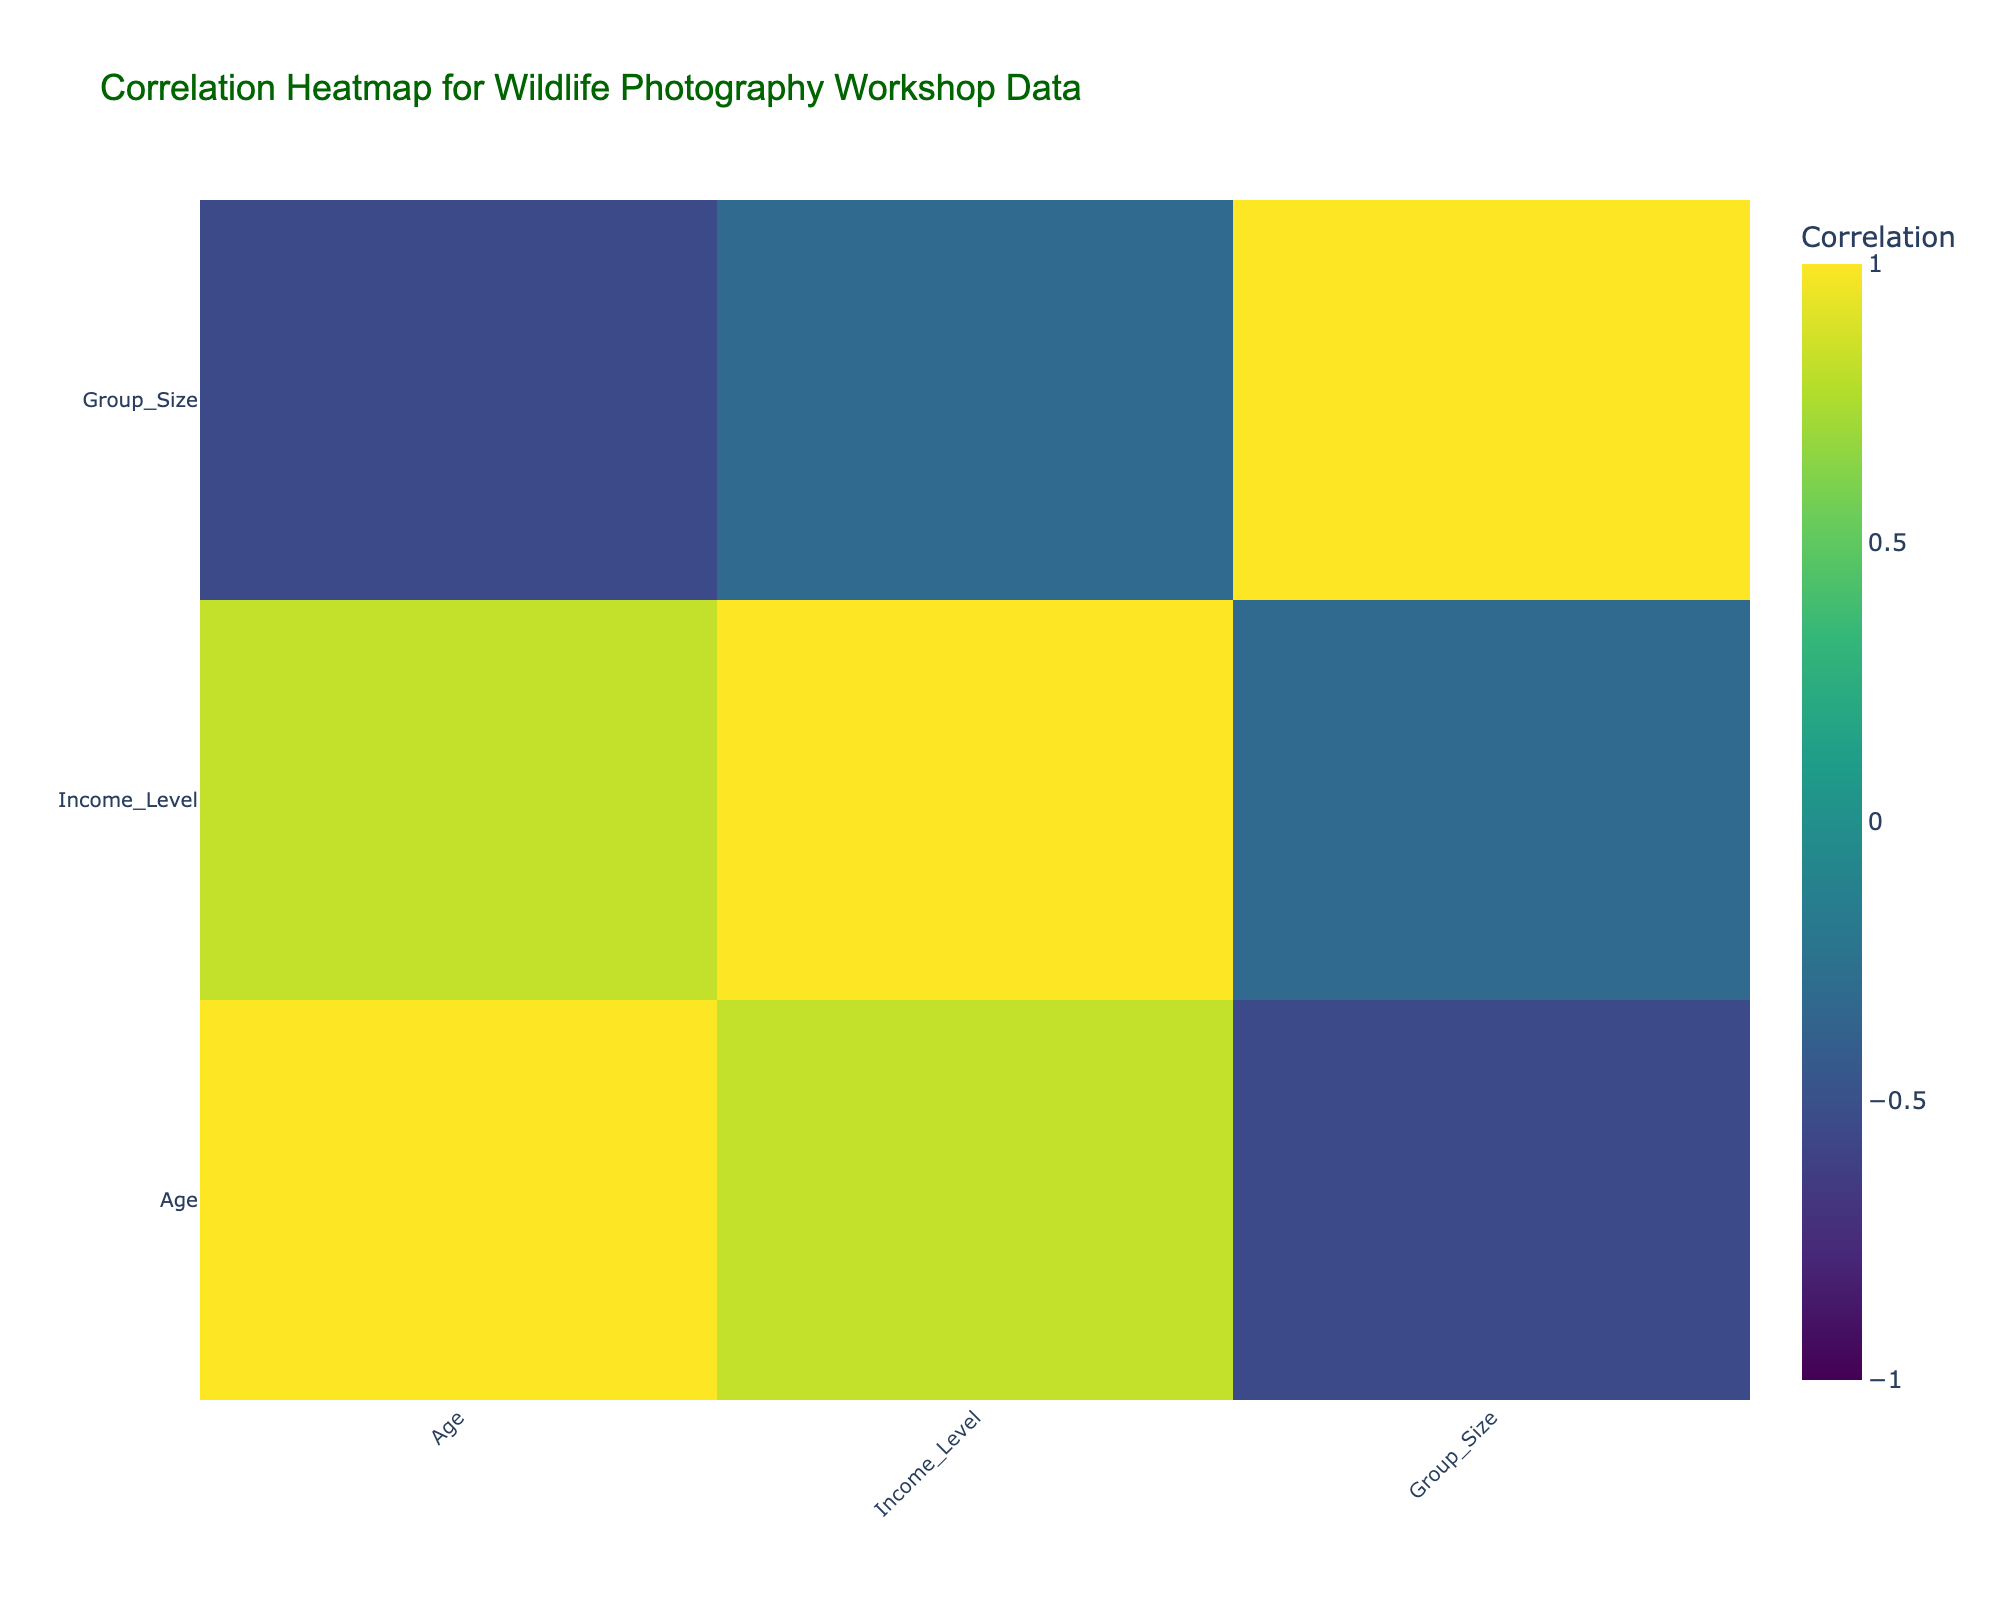What is the correlation between age and income level? The correlation table shows the values for age and income level. By looking at the intersection of the 'Age' row and 'Income Level' column, we can find the correlation value directly, which is positive.
Answer: Positive correlation Do older customers tend to have more previous photography experience? We compare the correlation between age and previous photography experience from the table. The values reveal a slight positive correlation indicating that older customers are generally more experienced in photography.
Answer: Yes What is the average preferred workshop length for customers with advanced photography experience? To calculate the average for advanced customers, we first filter the data for 'Advanced' experience, noting their preferred lengths (7, 10, and 8). Add them up: 7 + 10 + 8 = 25, and divide by 3 (the count of advanced customers), which equals approximately 8.33.
Answer: 8.33 Days Is there a relationship between group size and travel motivation? We look for correlations between the 'Group Size' and 'Travel Motivation' columns. The correlation values will help us determine if a relationship exists, assessing if they are related positively, negatively, or not at all. In this scenario, there is no strong correlation indicating that group size does not notably influence travel motivation.
Answer: No Which booking channel is correlated with the highest income level? Assess the correlation values between 'Booking Channel' and 'Income Level'. By examining these correlations, we can identify which channel has the strongest positive or negative correlation with income. In this case, booking through a travel agent correlates well with higher income levels.
Answer: Travel Agent 